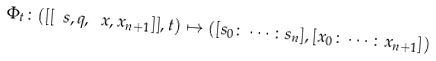<formula> <loc_0><loc_0><loc_500><loc_500>\Phi _ { t } \colon ( [ [ \ s , q , \ x , x _ { n + 1 } ] ] , t ) \mapsto ( [ s _ { 0 } \colon \cdots \colon s _ { n } ] , [ x _ { 0 } \colon \cdots \colon x _ { n + 1 } ] )</formula> 